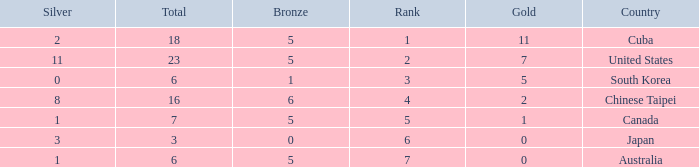What is the sum of the bronze medals when there were more than 2 silver medals and a rank larger than 6? None. 